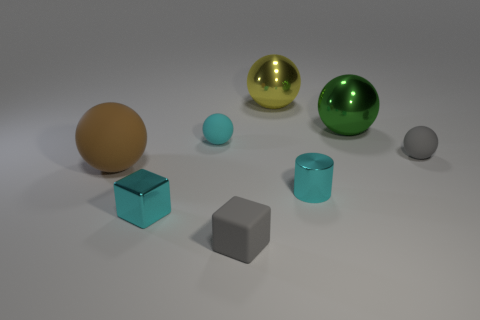Subtract all small balls. How many balls are left? 3 Subtract all brown balls. How many balls are left? 4 Add 2 large purple shiny cubes. How many objects exist? 10 Subtract 4 spheres. How many spheres are left? 1 Subtract all green cylinders. How many purple blocks are left? 0 Add 6 gray cubes. How many gray cubes exist? 7 Subtract 1 cyan cylinders. How many objects are left? 7 Subtract all balls. How many objects are left? 3 Subtract all yellow blocks. Subtract all blue balls. How many blocks are left? 2 Subtract all small metal cylinders. Subtract all brown spheres. How many objects are left? 6 